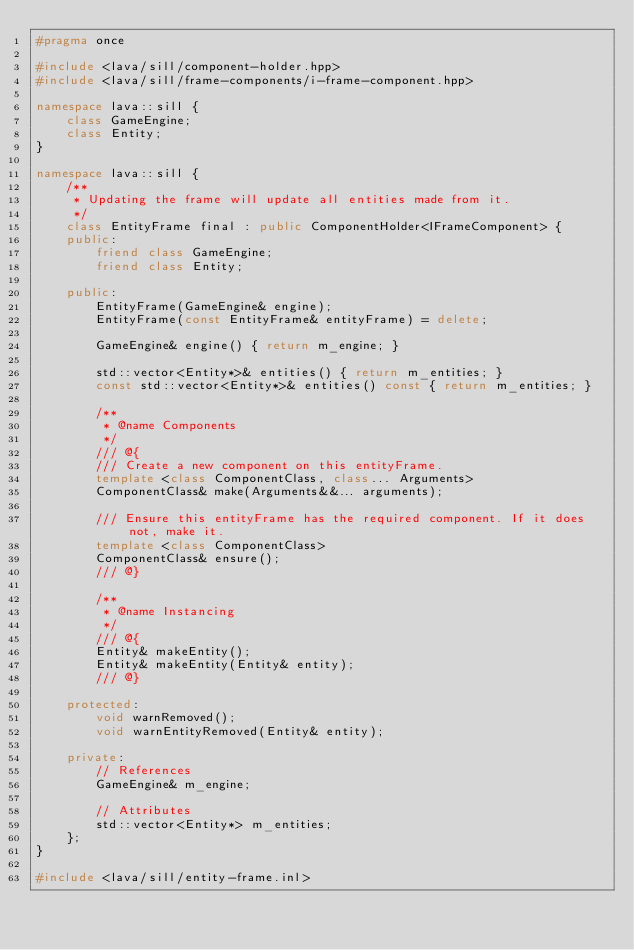Convert code to text. <code><loc_0><loc_0><loc_500><loc_500><_C++_>#pragma once

#include <lava/sill/component-holder.hpp>
#include <lava/sill/frame-components/i-frame-component.hpp>

namespace lava::sill {
    class GameEngine;
    class Entity;
}

namespace lava::sill {
    /**
     * Updating the frame will update all entities made from it.
     */
    class EntityFrame final : public ComponentHolder<IFrameComponent> {
    public:
        friend class GameEngine;
        friend class Entity;

    public:
        EntityFrame(GameEngine& engine);
        EntityFrame(const EntityFrame& entityFrame) = delete;

        GameEngine& engine() { return m_engine; }

        std::vector<Entity*>& entities() { return m_entities; }
        const std::vector<Entity*>& entities() const { return m_entities; }

        /**
         * @name Components
         */
        /// @{
        /// Create a new component on this entityFrame.
        template <class ComponentClass, class... Arguments>
        ComponentClass& make(Arguments&&... arguments);

        /// Ensure this entityFrame has the required component. If it does not, make it.
        template <class ComponentClass>
        ComponentClass& ensure();
        /// @}

        /**
         * @name Instancing
         */
        /// @{
        Entity& makeEntity();
        Entity& makeEntity(Entity& entity);
        /// @}

    protected:
        void warnRemoved();
        void warnEntityRemoved(Entity& entity);

    private:
        // References
        GameEngine& m_engine;

        // Attributes
        std::vector<Entity*> m_entities;
    };
}

#include <lava/sill/entity-frame.inl>
</code> 